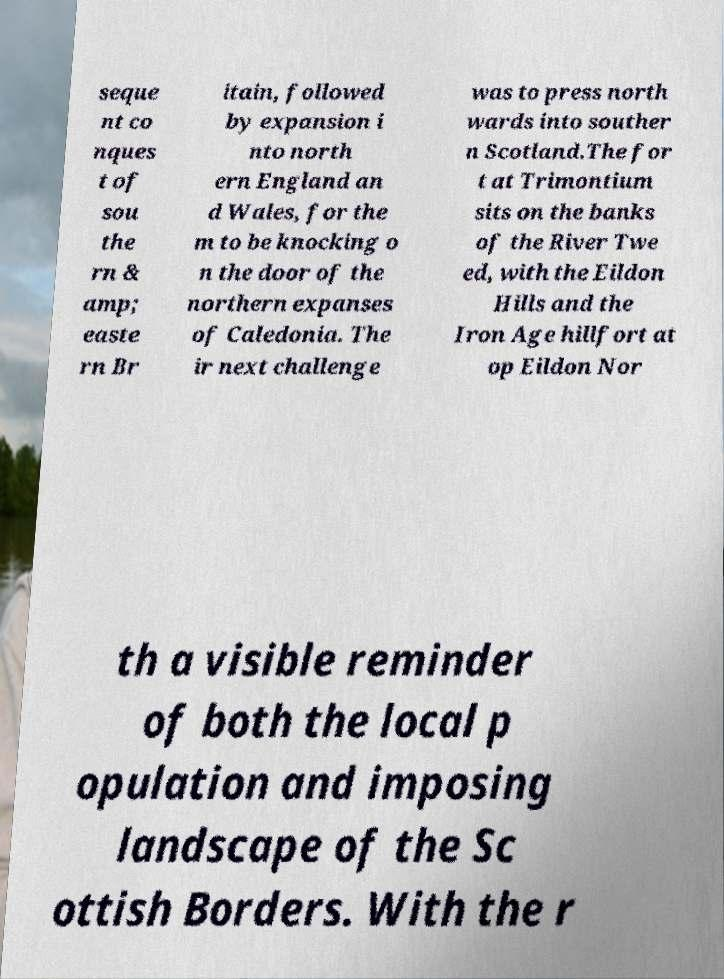Can you read and provide the text displayed in the image?This photo seems to have some interesting text. Can you extract and type it out for me? seque nt co nques t of sou the rn & amp; easte rn Br itain, followed by expansion i nto north ern England an d Wales, for the m to be knocking o n the door of the northern expanses of Caledonia. The ir next challenge was to press north wards into souther n Scotland.The for t at Trimontium sits on the banks of the River Twe ed, with the Eildon Hills and the Iron Age hillfort at op Eildon Nor th a visible reminder of both the local p opulation and imposing landscape of the Sc ottish Borders. With the r 